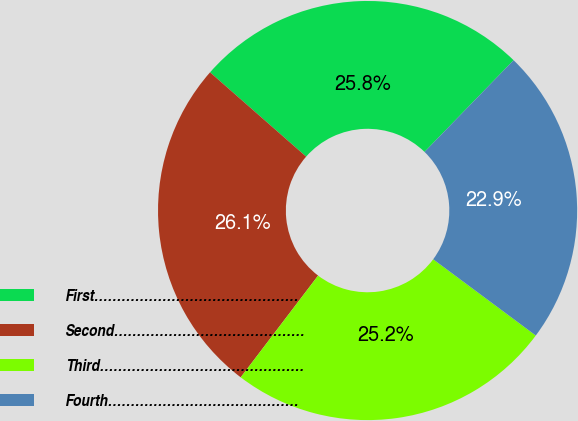Convert chart to OTSL. <chart><loc_0><loc_0><loc_500><loc_500><pie_chart><fcel>First………………………………………<fcel>Second……………………………………<fcel>Third………………………………………<fcel>Fourth……………………………………<nl><fcel>25.81%<fcel>26.11%<fcel>25.18%<fcel>22.9%<nl></chart> 